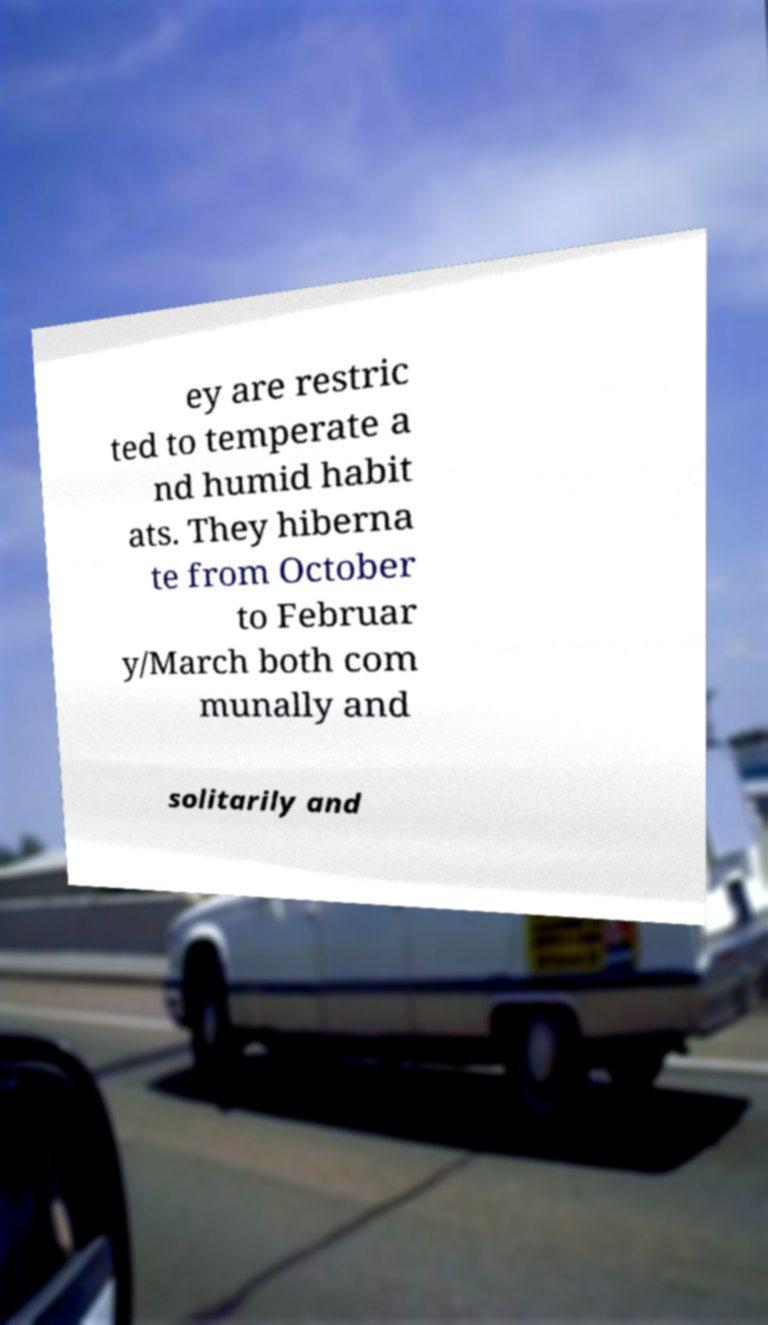Could you assist in decoding the text presented in this image and type it out clearly? ey are restric ted to temperate a nd humid habit ats. They hiberna te from October to Februar y/March both com munally and solitarily and 